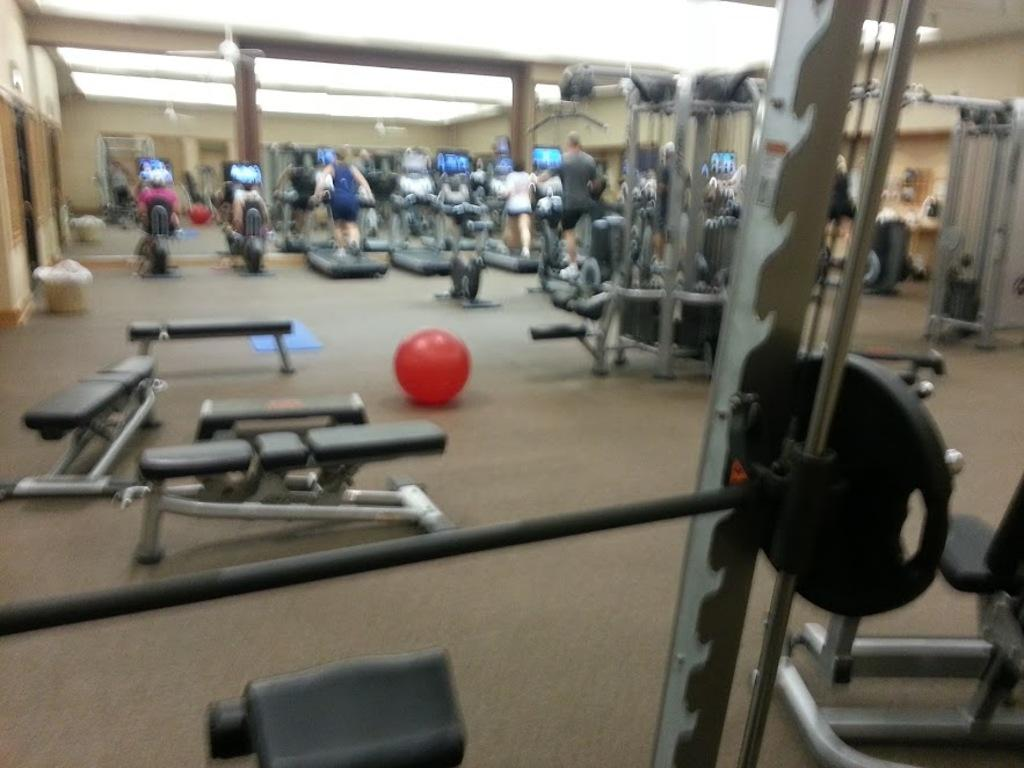Where was the image taken? The image was taken in a gym. What can be seen in the gym? There are people and gym equipment visible in the image. What is on the floor in the image? There is a red color ball on the floor. What type of history lesson is being taught in the gym in the image? There is no indication of a history lesson being taught in the gym in the image. 